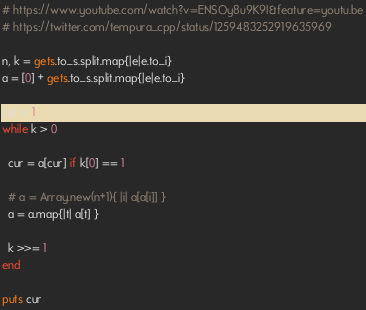<code> <loc_0><loc_0><loc_500><loc_500><_Ruby_># https://www.youtube.com/watch?v=ENSOy8u9K9I&feature=youtu.be
# https://twitter.com/tempura_cpp/status/1259483252919635969

n, k = gets.to_s.split.map{|e|e.to_i}
a = [0] + gets.to_s.split.map{|e|e.to_i}

cur = 1
while k > 0

  cur = a[cur] if k[0] == 1
  
  # a = Array.new(n+1){ |i| a[a[i]] }
  a = a.map{|t| a[t] }
  
  k >>= 1
end

puts cur</code> 